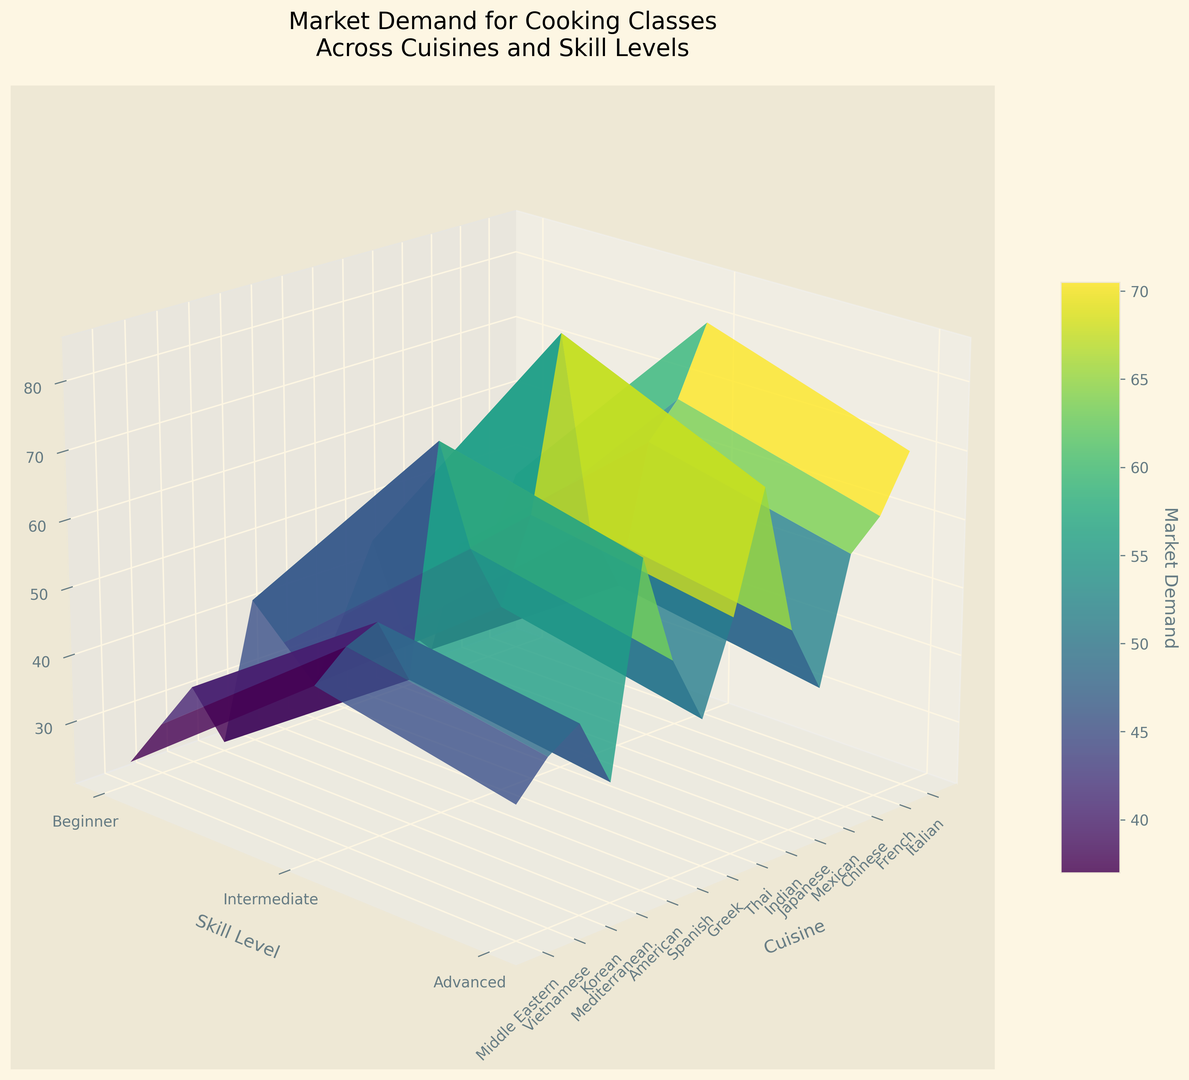Which cuisine has the highest market demand at the beginner skill level? To determine this, look at the heights of the surface plots where the skill level axis is set to “Beginner” and compare the values for different cuisines. The tallest surface corresponds to the cuisine with the highest demand.
Answer: Italian How does the market demand for French cooking classes compare between the intermediate and advanced skill levels? Observing the surface plot, compare the height at the "French" coordinate for both "Intermediate" and "Advanced" skill levels. The surface is higher for "Intermediate" skill levels than it is for "Advanced" ones.
Answer: Intermediate skill level has higher demand Which skill level generally shows the lowest market demand for cooking classes across all cuisines? Examine the overall height of the surface plots for each skill level. The "Advanced" skill level consistently has the lowest heights across most cuisines.
Answer: Advanced What is the difference in market demand for intermediate Mexican cooking classes versus intermediate Japanese cooking classes? Identify the surface heights at the "Intermediate" level for "Mexican" and "Japanese" cuisines. Subtract the height of Japanese from the height of Mexican.
Answer: 13 Which two cuisines have similar market demand at the advanced skill level, and what are their approximate demands? Look at the advanced skill level for values that are visually comparable. "Japanese" and "Chinese" advanced skill levels are roughly similar in height. Both are approximately around the 35-38 mark.
Answer: Japanese and Chinese; around 35-38 What is the average market demand for American cooking classes across all skill levels? Add the market demand values for American cuisine across all skill levels (Beginner, Intermediate, and Advanced) and divide by the number of skill levels (3). (80 + 70 + 48) / 3 = 198 / 3.
Answer: 66 Which cuisine shows the largest drop in market demand from beginner to advanced skill levels? Compare the heights at "Beginner" and "Advanced" levels for each cuisine and calculate the differences. The largest drop is seen in Chinese cuisine (70 - 38 = 32).
Answer: Chinese How does the market demand for beginner Mediterranean cooking classes compare to intermediate Greek cooking classes? Compare the height of the surface plot at the "Beginner" level for "Mediterranean" and at the "Intermediate" level for "Greek". Mediterranean "Beginner" is around 58 and Greek "Intermediate" is around 40.
Answer: Mediterranean beginner has higher demand Which cuisine has the lowest market demand at the intermediate skill level? Locate the surfaces associated with the "Intermediate" skill level and identify the shortest. Middle Eastern has the lowest demand at 38.
Answer: Middle Eastern What is the combined market demand for Thai cuisine classes at the beginner and intermediate skill levels? Add the demand values for Thai cuisine at the "Beginner" and "Intermediate" skill levels (50 + 45).
Answer: 95 